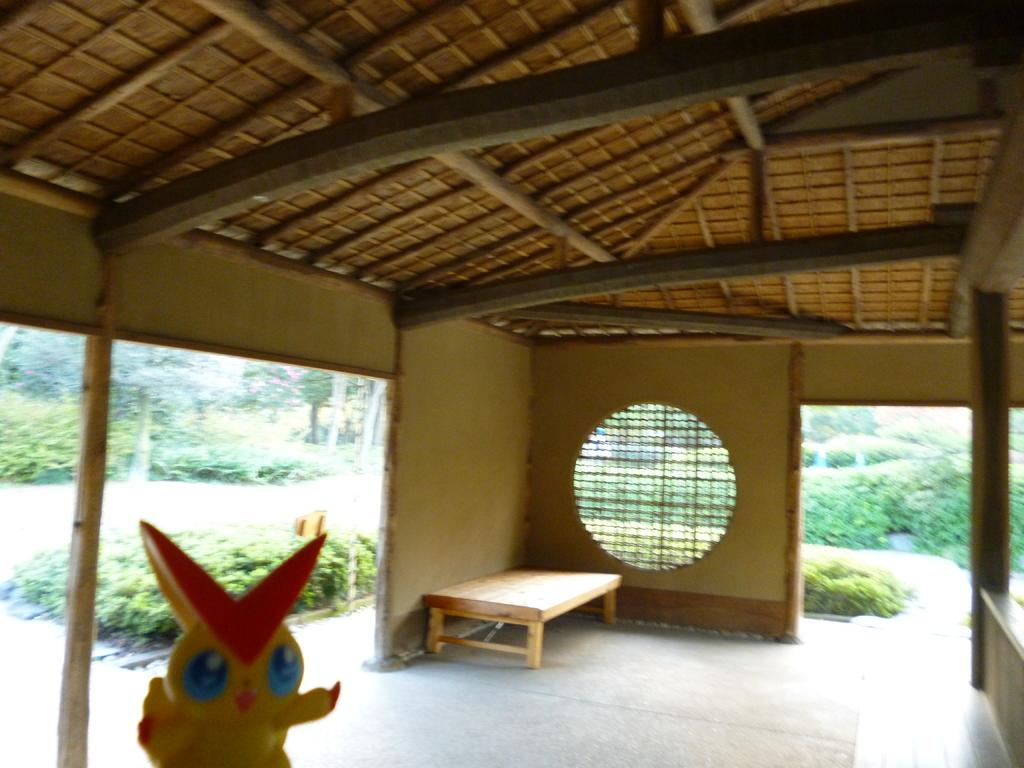Where is the image located in relation to the hut? The image is under a hut. What type of furniture is in the image? There is a bed in the image. What is on the bed? A cartoon is present on the bed. What type of barrier can be seen in the image? There is a fence in the image. What can be seen in the background of the image? There are trees in the background of the image. How many rabbits are hopping around the ant in the image? There are no rabbits or ants present in the image. 